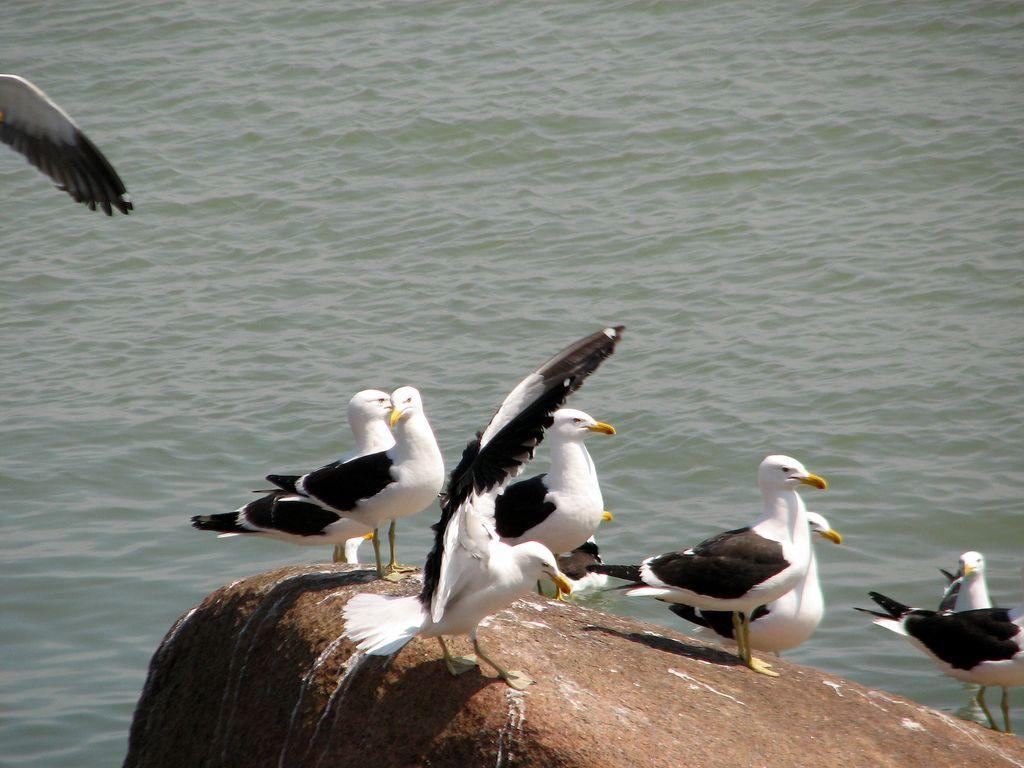What is the main subject of the image? The main subject of the image is birds on a rock. Can you describe the appearance of the birds? The birds are white and black in color. What else can be seen in the image besides the birds? There is water visible in the image. Is there any bird movement in the image? Yes, a bird is flying in the image. What type of silk fabric is draped over the building in the image? There is no building or silk fabric present in the image; it features birds on a rock and water. What is the voice of the bird saying in the image? The image does not provide any information about the birds' voices or what they might be saying. 